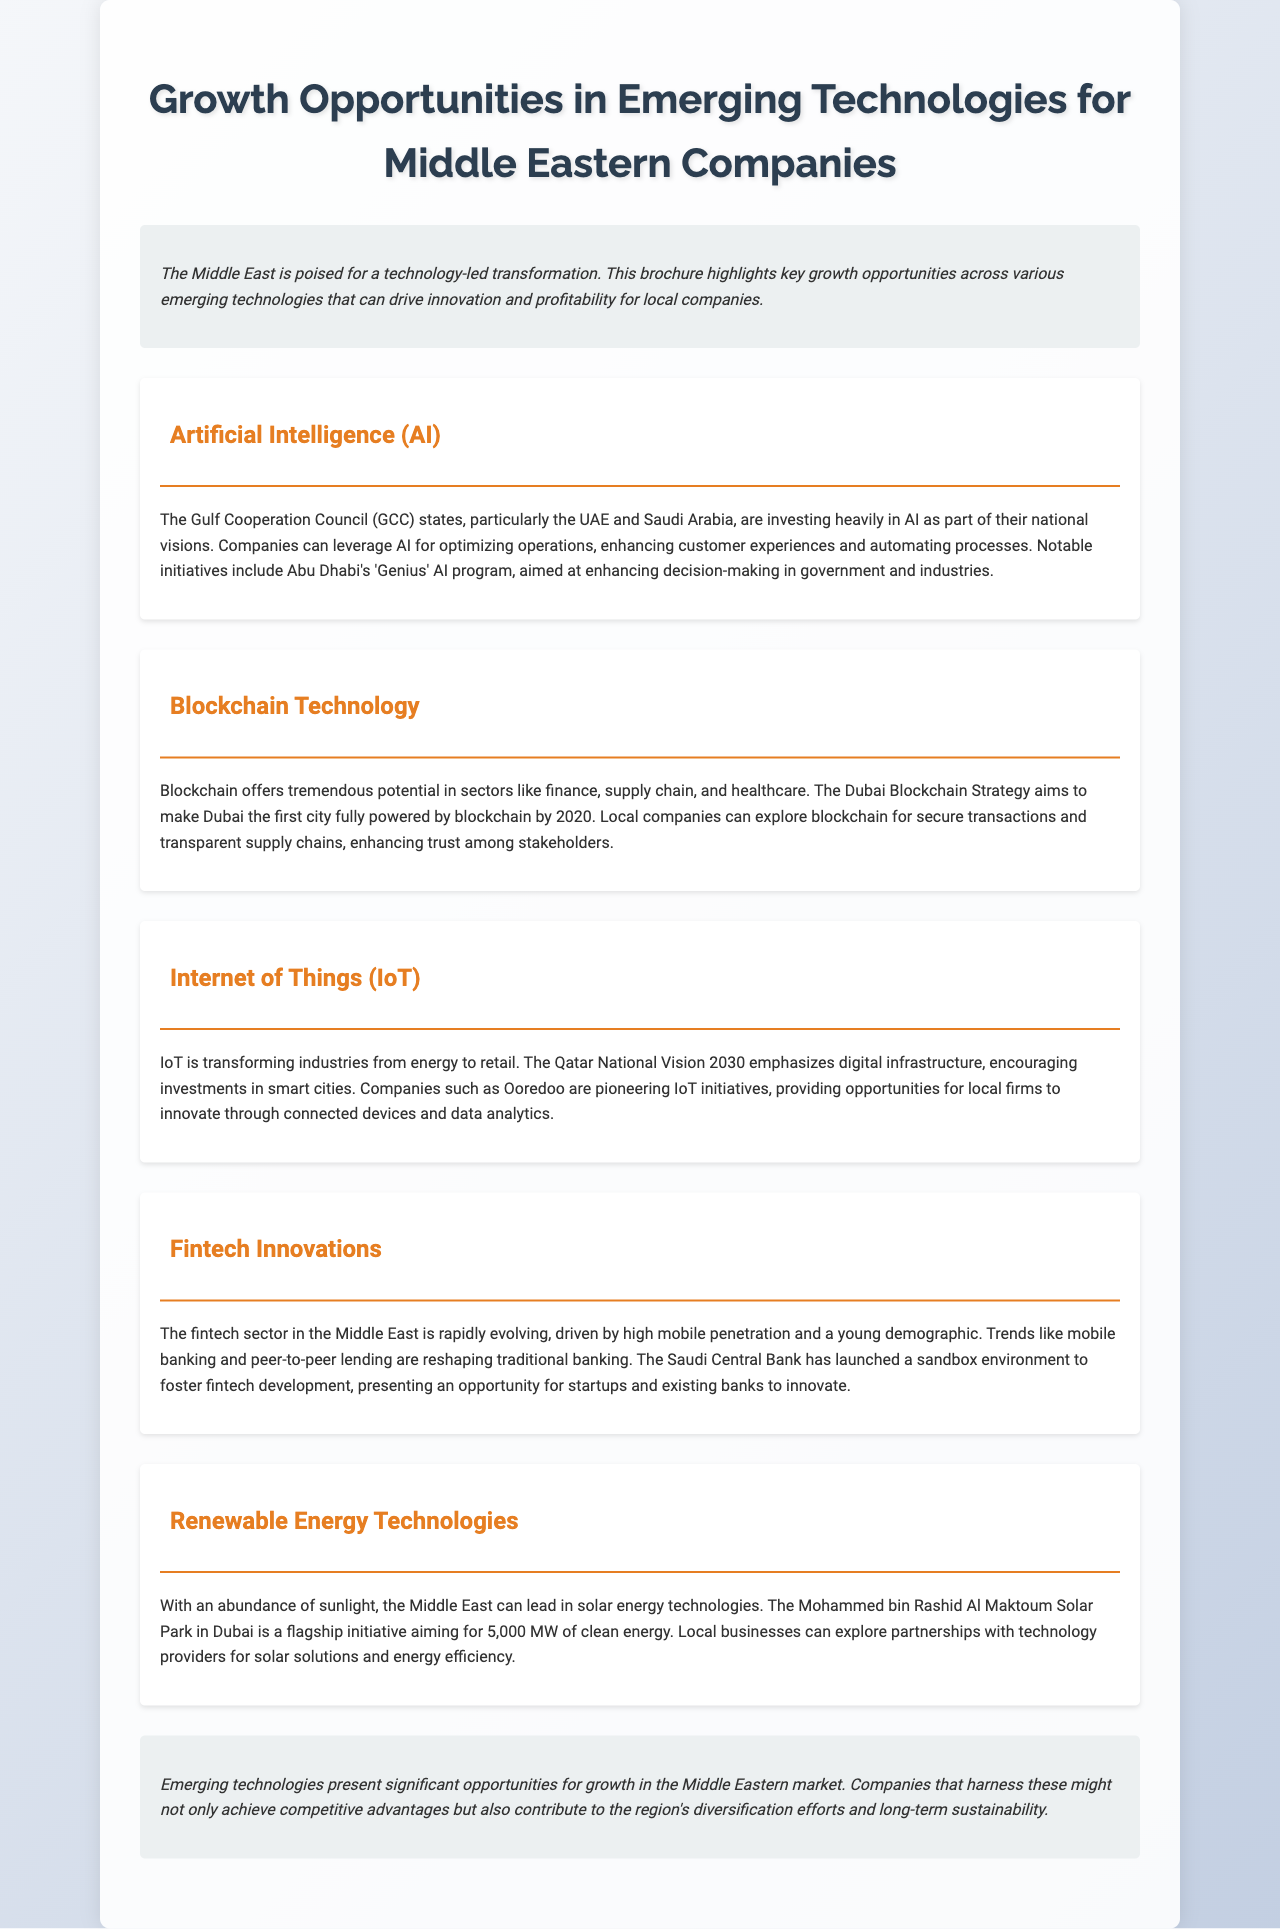What is the title of the brochure? The title is highlighted prominently at the top of the document.
Answer: Growth Opportunities in Emerging Technologies for Middle Eastern Companies What is the main focus of the brochure? The brochure outlines opportunities in emerging technologies for companies in the Middle East.
Answer: Emerging technologies Which cities are mentioned as investing in AI? The brochure mentions specific GCC states involved in AI initiatives.
Answer: UAE and Saudi Arabia What is the goal of the Dubai Blockchain Strategy? The document states a specific aim related to blockchain technology.
Answer: First city fully powered by blockchain What is the estimated capacity of the Mohammed bin Rashid Al Maktoum Solar Park? The brochure provides specific figures regarding the solar park's energy goals.
Answer: 5,000 MW What does the Qatar National Vision 2030 emphasize? The document references a national vision related to strategic planning.
Answer: Digital infrastructure What trend is reshaping traditional banking in the fintech sector? The brochure discusses specific trends affecting fintech in the Middle East.
Answer: Mobile banking Which initiative is aimed at enhancing decision-making in Abu Dhabi? The document references a specific program related to government and industry.
Answer: Genius AI program What type of environments has the Saudi Central Bank launched for fintech development? The brochure mentions a specific type of platform promoting innovation.
Answer: Sandbox environment 